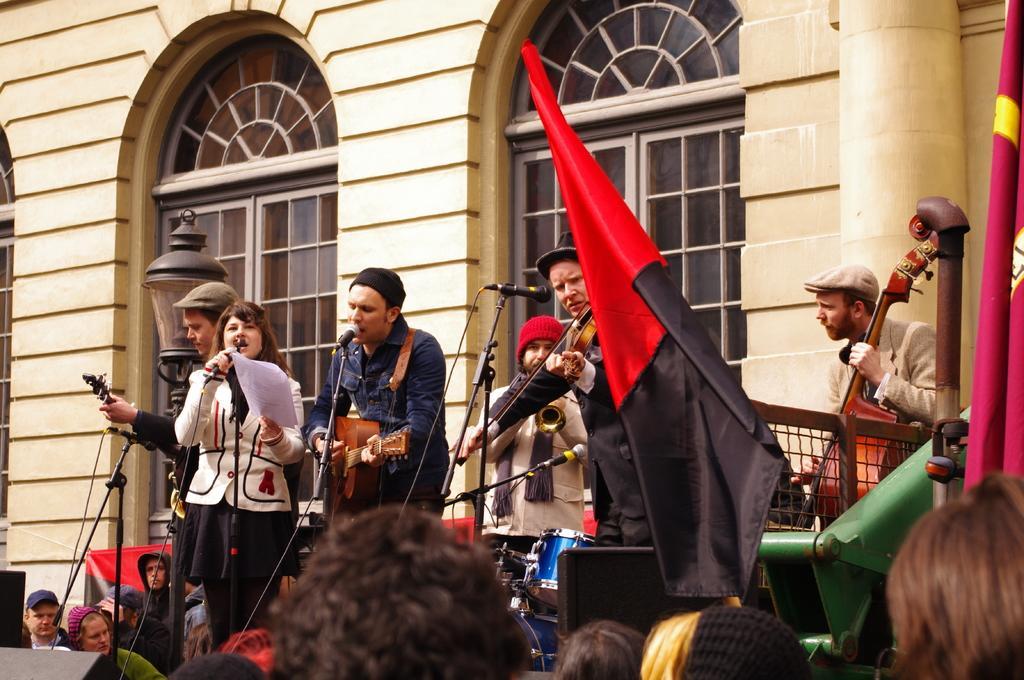Describe this image in one or two sentences. In this picture we can see some people standing here, these two persons are singing, here we can see three microphones, a violin and a guitar, in the background there is a building, we can see a window here, there is a cloth here, we can see drums here, there is a light here. 